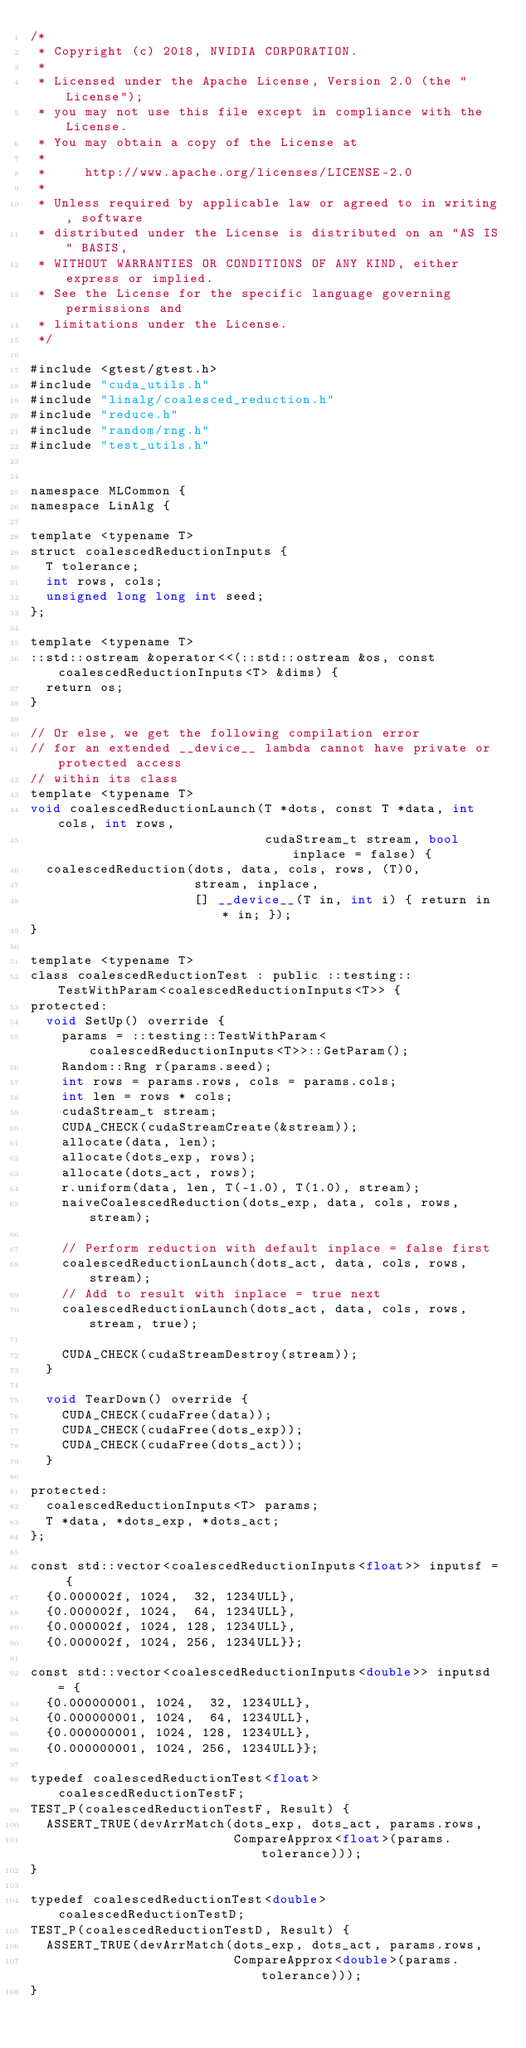Convert code to text. <code><loc_0><loc_0><loc_500><loc_500><_Cuda_>/*
 * Copyright (c) 2018, NVIDIA CORPORATION.
 *
 * Licensed under the Apache License, Version 2.0 (the "License");
 * you may not use this file except in compliance with the License.
 * You may obtain a copy of the License at
 *
 *     http://www.apache.org/licenses/LICENSE-2.0
 *
 * Unless required by applicable law or agreed to in writing, software
 * distributed under the License is distributed on an "AS IS" BASIS,
 * WITHOUT WARRANTIES OR CONDITIONS OF ANY KIND, either express or implied.
 * See the License for the specific language governing permissions and
 * limitations under the License.
 */

#include <gtest/gtest.h>
#include "cuda_utils.h"
#include "linalg/coalesced_reduction.h"
#include "reduce.h"
#include "random/rng.h"
#include "test_utils.h"


namespace MLCommon {
namespace LinAlg {

template <typename T>
struct coalescedReductionInputs {
  T tolerance;
  int rows, cols;
  unsigned long long int seed;
};

template <typename T>
::std::ostream &operator<<(::std::ostream &os, const coalescedReductionInputs<T> &dims) {
  return os;
}

// Or else, we get the following compilation error
// for an extended __device__ lambda cannot have private or protected access
// within its class
template <typename T>
void coalescedReductionLaunch(T *dots, const T *data, int cols, int rows,
                              cudaStream_t stream, bool inplace = false) {
  coalescedReduction(dots, data, cols, rows, (T)0,
                     stream, inplace,
                     [] __device__(T in, int i) { return in * in; });
}

template <typename T>
class coalescedReductionTest : public ::testing::TestWithParam<coalescedReductionInputs<T>> {
protected:
  void SetUp() override {
    params = ::testing::TestWithParam<coalescedReductionInputs<T>>::GetParam();
    Random::Rng r(params.seed);
    int rows = params.rows, cols = params.cols;
    int len = rows * cols;
    cudaStream_t stream;
    CUDA_CHECK(cudaStreamCreate(&stream));
    allocate(data, len);
    allocate(dots_exp, rows);
    allocate(dots_act, rows);
    r.uniform(data, len, T(-1.0), T(1.0), stream);
    naiveCoalescedReduction(dots_exp, data, cols, rows, stream);

    // Perform reduction with default inplace = false first
    coalescedReductionLaunch(dots_act, data, cols, rows, stream);
    // Add to result with inplace = true next
    coalescedReductionLaunch(dots_act, data, cols, rows, stream, true);

    CUDA_CHECK(cudaStreamDestroy(stream));
  }

  void TearDown() override {
    CUDA_CHECK(cudaFree(data));
    CUDA_CHECK(cudaFree(dots_exp));
    CUDA_CHECK(cudaFree(dots_act));
  }

protected:
  coalescedReductionInputs<T> params;
  T *data, *dots_exp, *dots_act;
};

const std::vector<coalescedReductionInputs<float>> inputsf = {
  {0.000002f, 1024,  32, 1234ULL},
  {0.000002f, 1024,  64, 1234ULL},
  {0.000002f, 1024, 128, 1234ULL},
  {0.000002f, 1024, 256, 1234ULL}};

const std::vector<coalescedReductionInputs<double>> inputsd = {
  {0.000000001, 1024,  32, 1234ULL},
  {0.000000001, 1024,  64, 1234ULL},
  {0.000000001, 1024, 128, 1234ULL},
  {0.000000001, 1024, 256, 1234ULL}};

typedef coalescedReductionTest<float> coalescedReductionTestF;
TEST_P(coalescedReductionTestF, Result) {
  ASSERT_TRUE(devArrMatch(dots_exp, dots_act, params.rows,
                          CompareApprox<float>(params.tolerance)));
}

typedef coalescedReductionTest<double> coalescedReductionTestD;
TEST_P(coalescedReductionTestD, Result) {
  ASSERT_TRUE(devArrMatch(dots_exp, dots_act, params.rows,
                          CompareApprox<double>(params.tolerance)));
}
</code> 